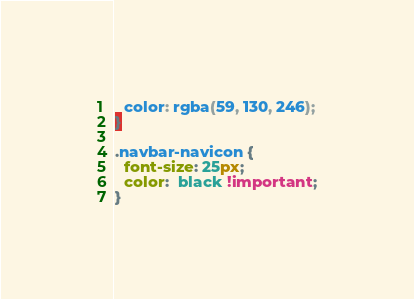Convert code to text. <code><loc_0><loc_0><loc_500><loc_500><_CSS_>  color: rgba(59, 130, 246);
}

.navbar-navicon {
  font-size: 25px;
  color:  black !important;
}
</code> 